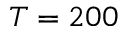Convert formula to latex. <formula><loc_0><loc_0><loc_500><loc_500>T = 2 0 0</formula> 